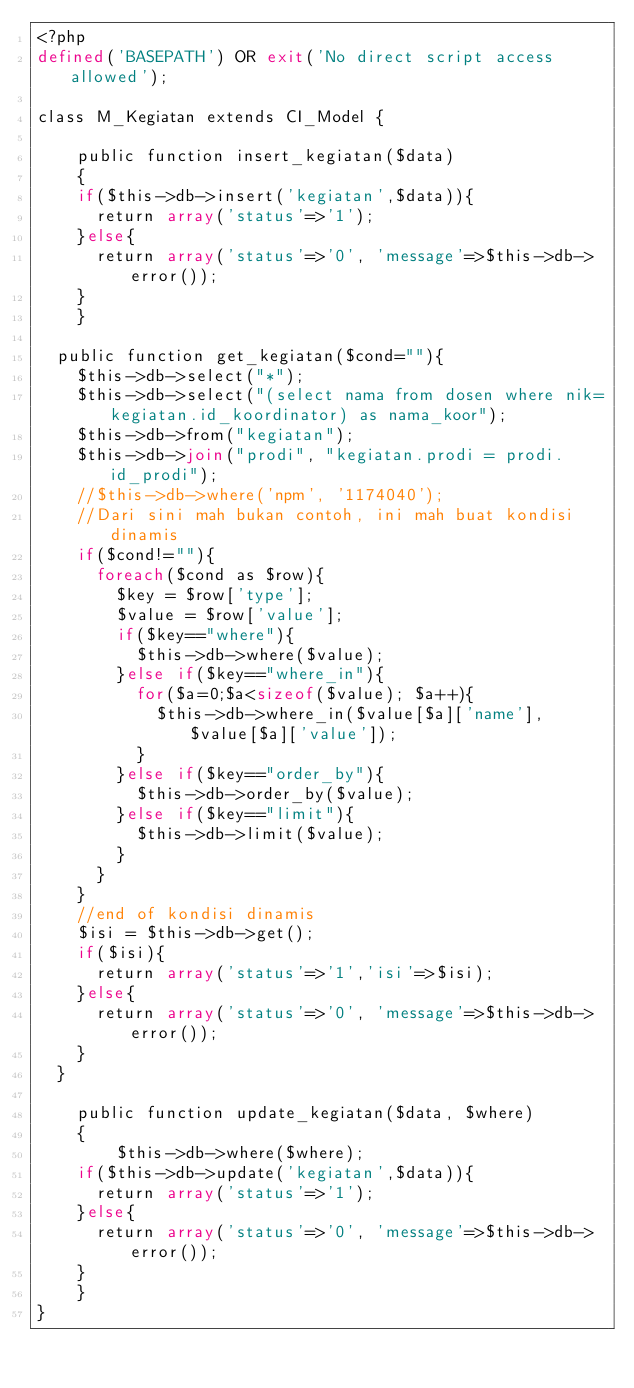Convert code to text. <code><loc_0><loc_0><loc_500><loc_500><_PHP_><?php
defined('BASEPATH') OR exit('No direct script access allowed');

class M_Kegiatan extends CI_Model {

	public function insert_kegiatan($data)
	{
    if($this->db->insert('kegiatan',$data)){
      return array('status'=>'1');
    }else{
      return array('status'=>'0', 'message'=>$this->db->error());
    }
	}

  public function get_kegiatan($cond=""){
    $this->db->select("*");
    $this->db->select("(select nama from dosen where nik=kegiatan.id_koordinator) as nama_koor");
    $this->db->from("kegiatan");
    $this->db->join("prodi", "kegiatan.prodi = prodi.id_prodi");
    //$this->db->where('npm', '1174040');
    //Dari sini mah bukan contoh, ini mah buat kondisi dinamis
    if($cond!=""){
      foreach($cond as $row){
        $key = $row['type'];
        $value = $row['value'];
        if($key=="where"){
          $this->db->where($value);
        }else if($key=="where_in"){
          for($a=0;$a<sizeof($value); $a++){
            $this->db->where_in($value[$a]['name'], $value[$a]['value']);
          }
        }else if($key=="order_by"){
          $this->db->order_by($value);
        }else if($key=="limit"){
          $this->db->limit($value);
        }
      }
    }
    //end of kondisi dinamis
    $isi = $this->db->get();
    if($isi){
      return array('status'=>'1','isi'=>$isi);
    }else{
      return array('status'=>'0', 'message'=>$this->db->error());
    }
  }

	public function update_kegiatan($data, $where)
	{
		$this->db->where($where);
    if($this->db->update('kegiatan',$data)){
      return array('status'=>'1');
    }else{
      return array('status'=>'0', 'message'=>$this->db->error());
    }
	}
}
</code> 